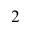<formula> <loc_0><loc_0><loc_500><loc_500>2</formula> 